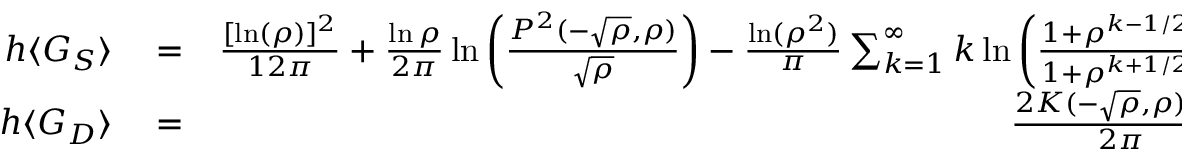Convert formula to latex. <formula><loc_0><loc_0><loc_500><loc_500>\begin{array} { r l r } { h \langle G _ { S } \rangle } & = } & { \frac { [ \ln ( \rho ) ] ^ { 2 } } { 1 2 \pi } + \frac { \ln \rho } { 2 \pi } \ln \left ( \frac { P ^ { 2 } ( - \sqrt { \rho } , \rho ) } { \sqrt { \rho } } \right ) - \frac { \ln ( \rho ^ { 2 } ) } { \pi } \sum _ { k = 1 } ^ { \infty } k \ln \left ( \frac { 1 + \rho ^ { k - 1 / 2 } } { 1 + \rho ^ { k + 1 / 2 } } \right ) , } \\ { h \langle G _ { D } \rangle } & = } & { \frac { 2 K ( - \sqrt { \rho } , \rho ) - 1 } { 2 \pi } } \end{array}</formula> 